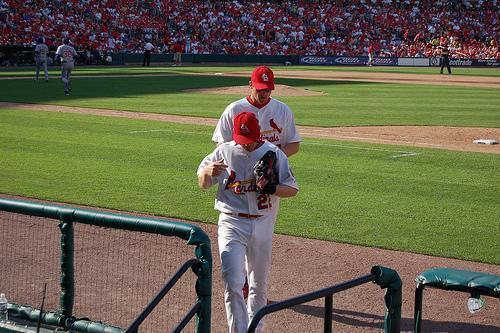How many players are running towards the camera?
Give a very brief answer. 2. 